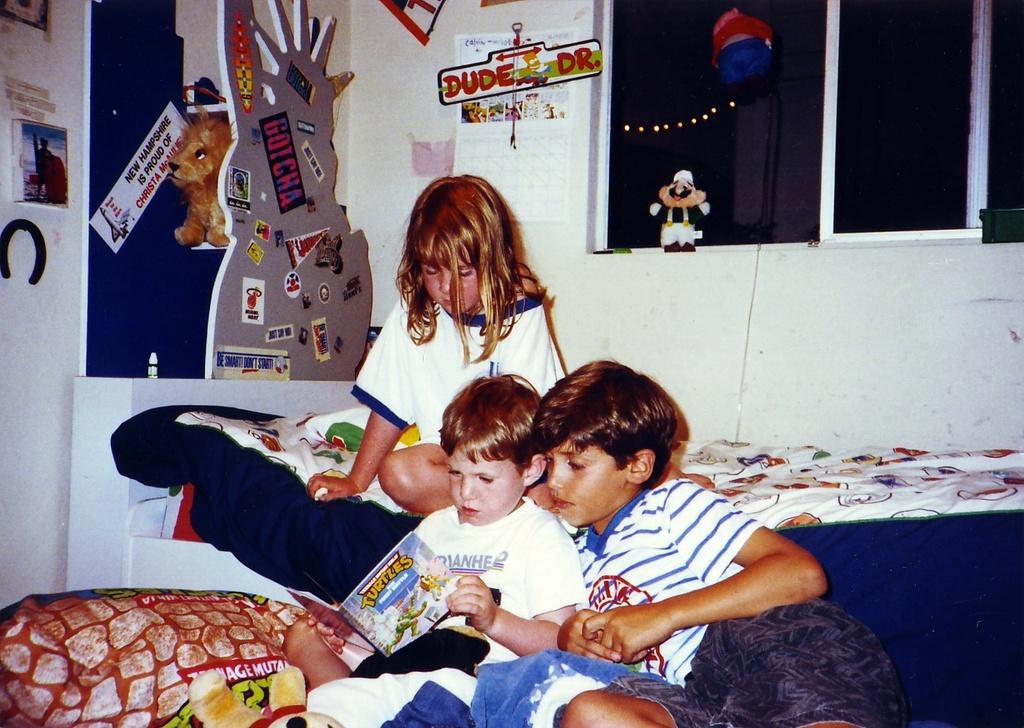What type of structure can be seen in the image? There is a wall in the image. What is hanging on the wall? There is a poster in the image. What allows natural light to enter the room in the image? There are windows in the image. What type of object is present in the image that is typically associated with play? There is a toy in the image. What are the people in the image doing? There are people sitting on beds in the image. What type of farm animals can be seen grazing on the roof in the image? There is no roof or farm animals present in the image. What type of beam is supporting the structure in the image? There is no beam visible in the image, and the structure is not described in the provided facts. 